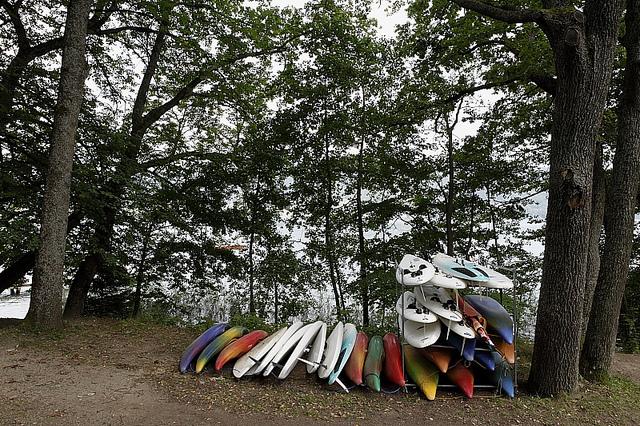What items are being shown?
Concise answer only. Surfboards. Is this next to a lake?
Be succinct. Yes. How many people are here?
Be succinct. 0. 